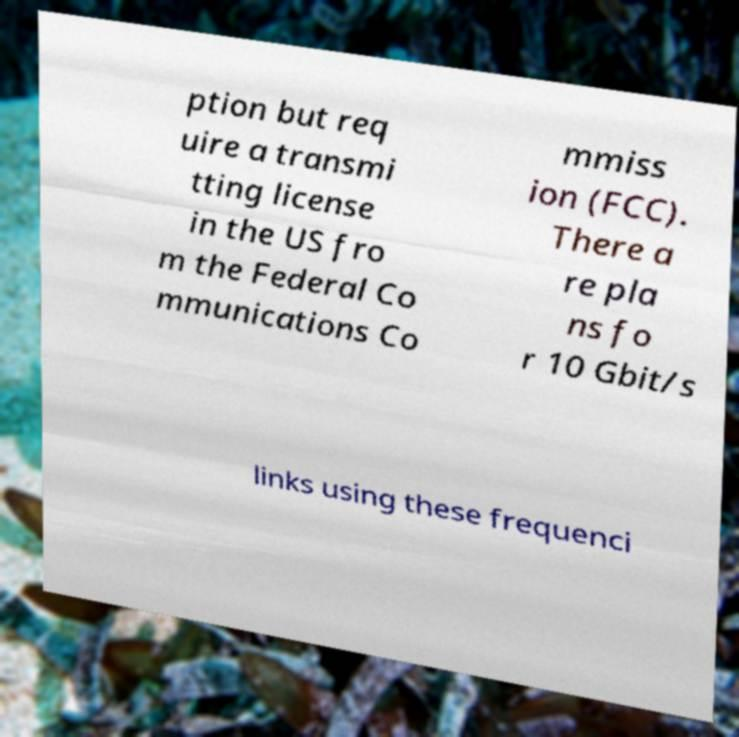Can you read and provide the text displayed in the image?This photo seems to have some interesting text. Can you extract and type it out for me? ption but req uire a transmi tting license in the US fro m the Federal Co mmunications Co mmiss ion (FCC). There a re pla ns fo r 10 Gbit/s links using these frequenci 